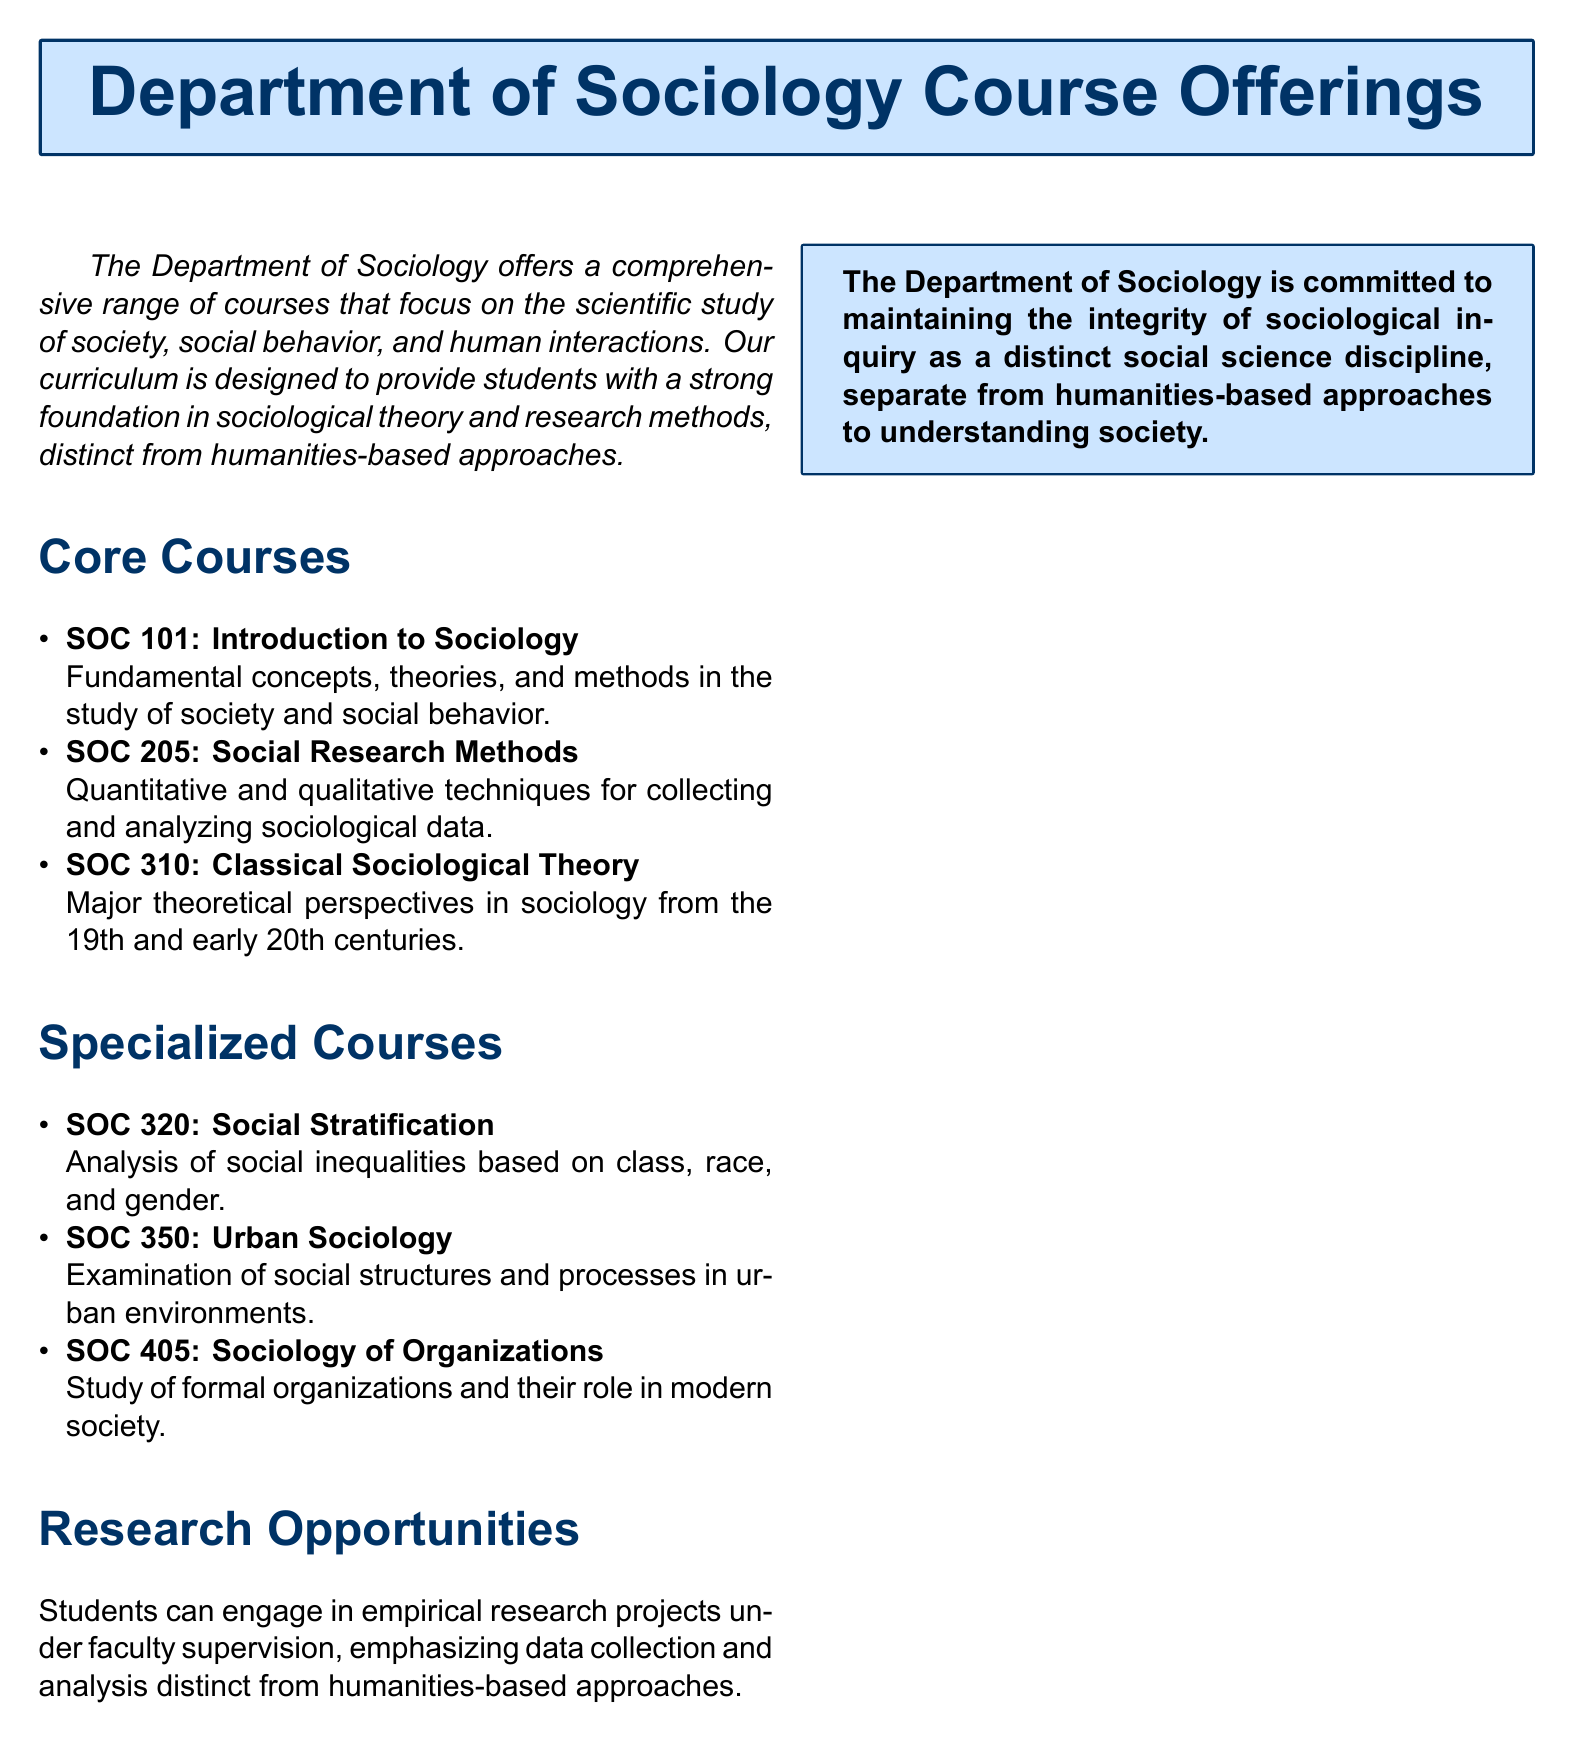What is the title of the document? The title is found in the heading section of the document.
Answer: Department of Sociology Course Offerings How many core courses are listed? The number of core courses is counted from the core courses section in the document.
Answer: 3 What is the course code for Urban Sociology? The course code is derived from the specialized courses section in the document.
Answer: SOC 350 Which course focuses on social inequalities? The course that deals with social inequalities is found in the specialized courses section.
Answer: SOC 320: Social Stratification What is emphasized in the research opportunities? The focus of research opportunities is highlighted in the corresponding section.
Answer: Data collection and analysis What theoretical perspective is covered in SOC 310? This course's focus is specified in the core courses section.
Answer: Classical Sociological Theory What distinguishes sociology from humanities in this department? The distinction is stated in the introduction and concluding statements.
Answer: Sociological inquiry as a distinct social science discipline 